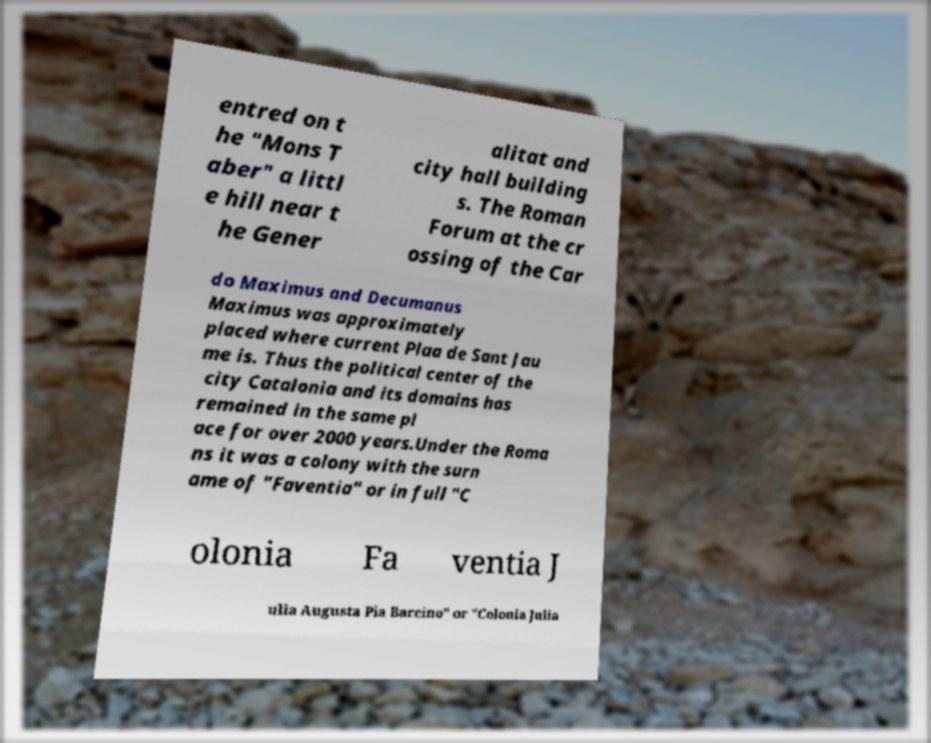What messages or text are displayed in this image? I need them in a readable, typed format. entred on t he "Mons T aber" a littl e hill near t he Gener alitat and city hall building s. The Roman Forum at the cr ossing of the Car do Maximus and Decumanus Maximus was approximately placed where current Plaa de Sant Jau me is. Thus the political center of the city Catalonia and its domains has remained in the same pl ace for over 2000 years.Under the Roma ns it was a colony with the surn ame of "Faventia" or in full "C olonia Fa ventia J ulia Augusta Pia Barcino" or "Colonia Julia 